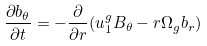Convert formula to latex. <formula><loc_0><loc_0><loc_500><loc_500>\frac { \partial b _ { \theta } } { \partial t } = - \frac { \partial } { \partial r } ( u _ { 1 } ^ { g } B _ { \theta } - r \Omega _ { g } b _ { r } )</formula> 